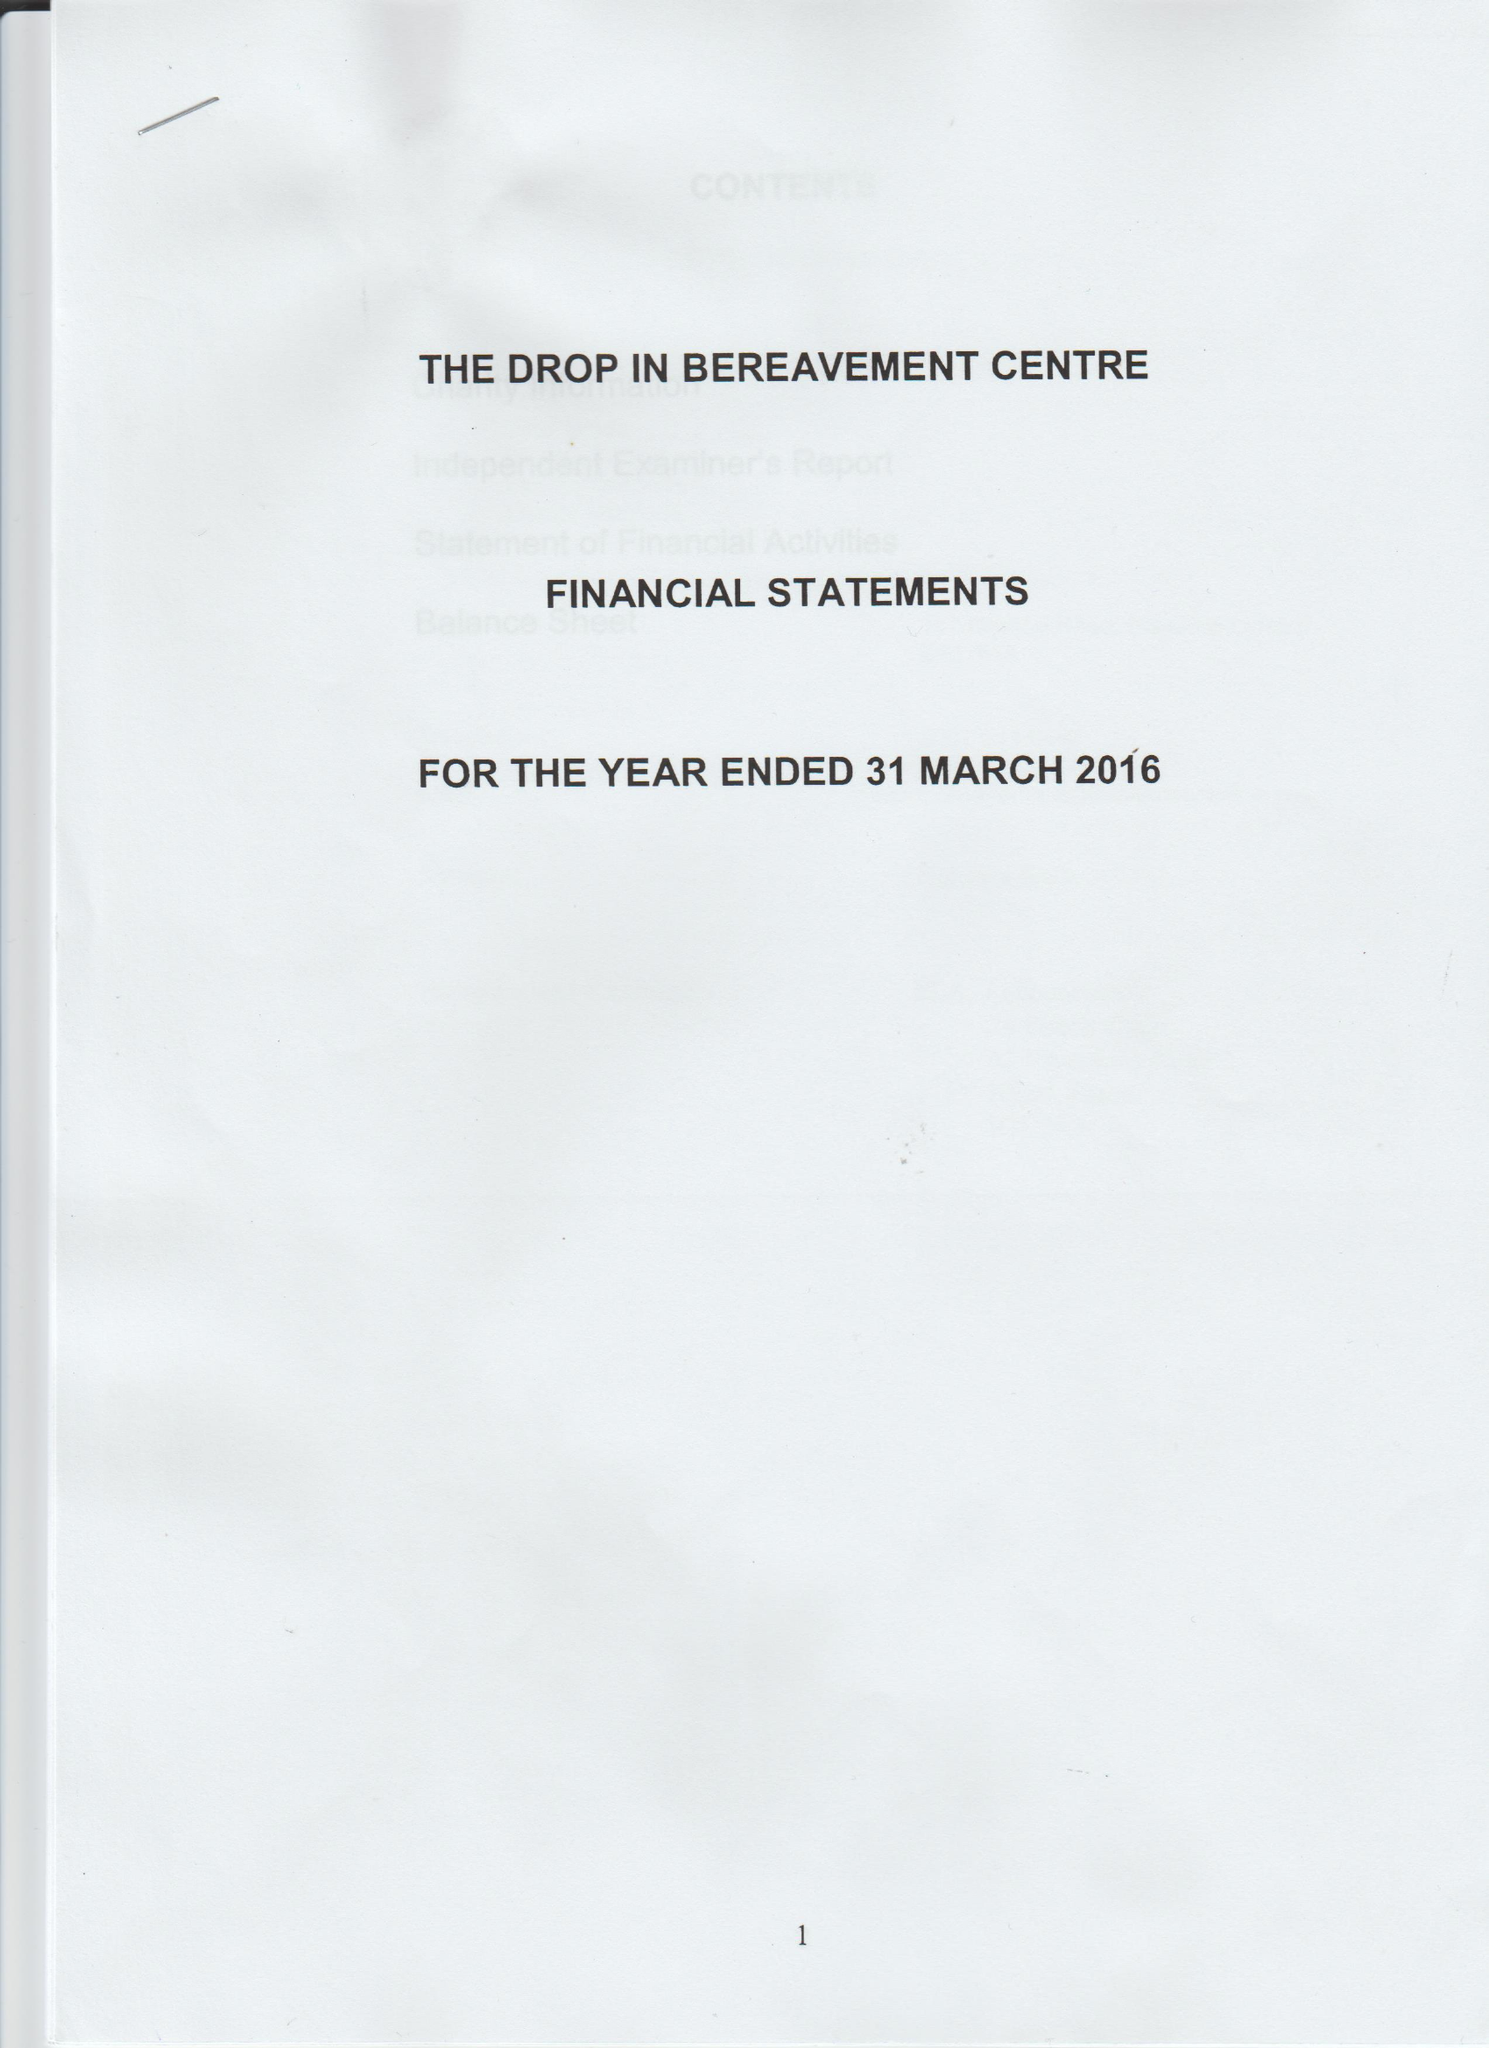What is the value for the charity_name?
Answer the question using a single word or phrase. The Drop In Bereavement Centre 